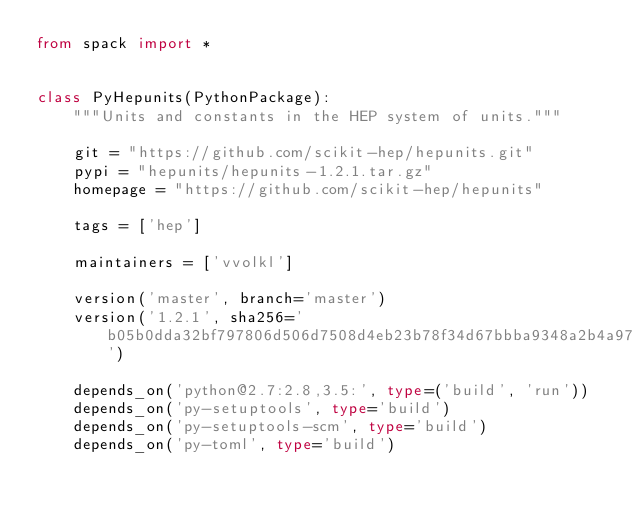<code> <loc_0><loc_0><loc_500><loc_500><_Python_>from spack import *


class PyHepunits(PythonPackage):
    """Units and constants in the HEP system of units."""

    git = "https://github.com/scikit-hep/hepunits.git"
    pypi = "hepunits/hepunits-1.2.1.tar.gz"
    homepage = "https://github.com/scikit-hep/hepunits"

    tags = ['hep']

    maintainers = ['vvolkl']

    version('master', branch='master')
    version('1.2.1', sha256='b05b0dda32bf797806d506d7508d4eb23b78f34d67bbba9348a2b4a9712666fa')

    depends_on('python@2.7:2.8,3.5:', type=('build', 'run'))
    depends_on('py-setuptools', type='build')
    depends_on('py-setuptools-scm', type='build')
    depends_on('py-toml', type='build')
</code> 